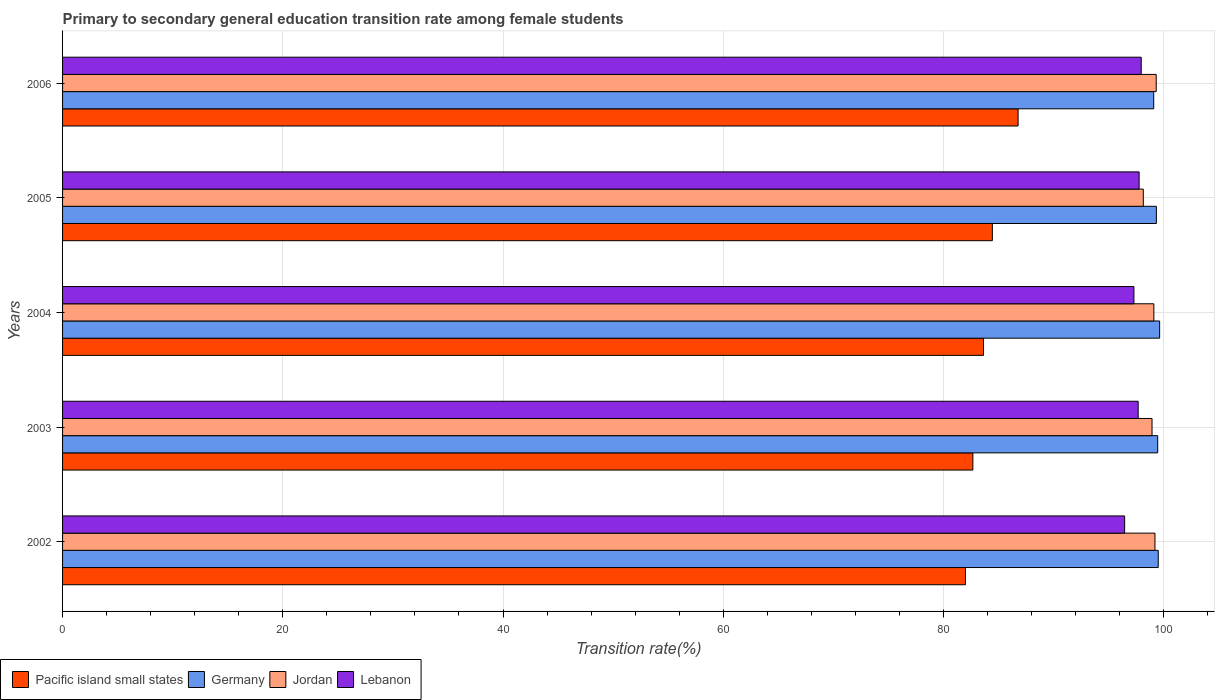Are the number of bars per tick equal to the number of legend labels?
Make the answer very short. Yes. How many bars are there on the 2nd tick from the top?
Provide a short and direct response. 4. How many bars are there on the 3rd tick from the bottom?
Offer a very short reply. 4. What is the label of the 3rd group of bars from the top?
Offer a very short reply. 2004. What is the transition rate in Pacific island small states in 2002?
Provide a short and direct response. 82. Across all years, what is the maximum transition rate in Pacific island small states?
Provide a short and direct response. 86.78. Across all years, what is the minimum transition rate in Lebanon?
Your answer should be compact. 96.46. In which year was the transition rate in Germany maximum?
Keep it short and to the point. 2004. In which year was the transition rate in Germany minimum?
Keep it short and to the point. 2006. What is the total transition rate in Germany in the graph?
Offer a terse response. 497.04. What is the difference between the transition rate in Jordan in 2002 and that in 2006?
Provide a succinct answer. -0.11. What is the difference between the transition rate in Lebanon in 2006 and the transition rate in Jordan in 2003?
Provide a short and direct response. -0.98. What is the average transition rate in Germany per year?
Make the answer very short. 99.41. In the year 2004, what is the difference between the transition rate in Germany and transition rate in Jordan?
Offer a very short reply. 0.52. What is the ratio of the transition rate in Lebanon in 2005 to that in 2006?
Make the answer very short. 1. Is the difference between the transition rate in Germany in 2005 and 2006 greater than the difference between the transition rate in Jordan in 2005 and 2006?
Give a very brief answer. Yes. What is the difference between the highest and the second highest transition rate in Pacific island small states?
Offer a very short reply. 2.34. What is the difference between the highest and the lowest transition rate in Germany?
Make the answer very short. 0.54. In how many years, is the transition rate in Lebanon greater than the average transition rate in Lebanon taken over all years?
Your answer should be compact. 3. Is the sum of the transition rate in Lebanon in 2004 and 2005 greater than the maximum transition rate in Jordan across all years?
Provide a succinct answer. Yes. What does the 3rd bar from the top in 2004 represents?
Your response must be concise. Germany. What does the 1st bar from the bottom in 2003 represents?
Give a very brief answer. Pacific island small states. Is it the case that in every year, the sum of the transition rate in Pacific island small states and transition rate in Germany is greater than the transition rate in Lebanon?
Your answer should be very brief. Yes. How many bars are there?
Make the answer very short. 20. Are all the bars in the graph horizontal?
Your answer should be very brief. Yes. How many years are there in the graph?
Keep it short and to the point. 5. What is the difference between two consecutive major ticks on the X-axis?
Offer a very short reply. 20. Are the values on the major ticks of X-axis written in scientific E-notation?
Make the answer very short. No. Where does the legend appear in the graph?
Your answer should be very brief. Bottom left. How are the legend labels stacked?
Keep it short and to the point. Horizontal. What is the title of the graph?
Your response must be concise. Primary to secondary general education transition rate among female students. What is the label or title of the X-axis?
Provide a short and direct response. Transition rate(%). What is the Transition rate(%) of Pacific island small states in 2002?
Provide a succinct answer. 82. What is the Transition rate(%) of Germany in 2002?
Your answer should be compact. 99.51. What is the Transition rate(%) of Jordan in 2002?
Offer a terse response. 99.21. What is the Transition rate(%) of Lebanon in 2002?
Keep it short and to the point. 96.46. What is the Transition rate(%) of Pacific island small states in 2003?
Make the answer very short. 82.67. What is the Transition rate(%) of Germany in 2003?
Ensure brevity in your answer.  99.46. What is the Transition rate(%) of Jordan in 2003?
Provide a short and direct response. 98.95. What is the Transition rate(%) of Lebanon in 2003?
Offer a very short reply. 97.69. What is the Transition rate(%) of Pacific island small states in 2004?
Your answer should be compact. 83.64. What is the Transition rate(%) in Germany in 2004?
Your answer should be very brief. 99.64. What is the Transition rate(%) in Jordan in 2004?
Your response must be concise. 99.11. What is the Transition rate(%) in Lebanon in 2004?
Provide a succinct answer. 97.3. What is the Transition rate(%) of Pacific island small states in 2005?
Keep it short and to the point. 84.44. What is the Transition rate(%) of Germany in 2005?
Offer a very short reply. 99.34. What is the Transition rate(%) in Jordan in 2005?
Provide a short and direct response. 98.15. What is the Transition rate(%) of Lebanon in 2005?
Provide a succinct answer. 97.77. What is the Transition rate(%) in Pacific island small states in 2006?
Provide a succinct answer. 86.78. What is the Transition rate(%) of Germany in 2006?
Your answer should be very brief. 99.1. What is the Transition rate(%) of Jordan in 2006?
Provide a short and direct response. 99.33. What is the Transition rate(%) of Lebanon in 2006?
Provide a short and direct response. 97.96. Across all years, what is the maximum Transition rate(%) of Pacific island small states?
Your response must be concise. 86.78. Across all years, what is the maximum Transition rate(%) of Germany?
Your answer should be compact. 99.64. Across all years, what is the maximum Transition rate(%) of Jordan?
Keep it short and to the point. 99.33. Across all years, what is the maximum Transition rate(%) of Lebanon?
Keep it short and to the point. 97.96. Across all years, what is the minimum Transition rate(%) of Pacific island small states?
Provide a short and direct response. 82. Across all years, what is the minimum Transition rate(%) of Germany?
Your answer should be very brief. 99.1. Across all years, what is the minimum Transition rate(%) of Jordan?
Keep it short and to the point. 98.15. Across all years, what is the minimum Transition rate(%) in Lebanon?
Give a very brief answer. 96.46. What is the total Transition rate(%) of Pacific island small states in the graph?
Offer a terse response. 419.54. What is the total Transition rate(%) in Germany in the graph?
Provide a short and direct response. 497.04. What is the total Transition rate(%) in Jordan in the graph?
Your answer should be compact. 494.75. What is the total Transition rate(%) of Lebanon in the graph?
Your answer should be very brief. 487.18. What is the difference between the Transition rate(%) in Pacific island small states in 2002 and that in 2003?
Ensure brevity in your answer.  -0.67. What is the difference between the Transition rate(%) of Germany in 2002 and that in 2003?
Your response must be concise. 0.05. What is the difference between the Transition rate(%) in Jordan in 2002 and that in 2003?
Your answer should be very brief. 0.27. What is the difference between the Transition rate(%) in Lebanon in 2002 and that in 2003?
Your response must be concise. -1.23. What is the difference between the Transition rate(%) in Pacific island small states in 2002 and that in 2004?
Your answer should be compact. -1.64. What is the difference between the Transition rate(%) of Germany in 2002 and that in 2004?
Provide a short and direct response. -0.13. What is the difference between the Transition rate(%) in Jordan in 2002 and that in 2004?
Ensure brevity in your answer.  0.1. What is the difference between the Transition rate(%) of Lebanon in 2002 and that in 2004?
Your answer should be compact. -0.84. What is the difference between the Transition rate(%) in Pacific island small states in 2002 and that in 2005?
Your answer should be very brief. -2.44. What is the difference between the Transition rate(%) in Germany in 2002 and that in 2005?
Keep it short and to the point. 0.17. What is the difference between the Transition rate(%) in Jordan in 2002 and that in 2005?
Ensure brevity in your answer.  1.06. What is the difference between the Transition rate(%) of Lebanon in 2002 and that in 2005?
Your response must be concise. -1.32. What is the difference between the Transition rate(%) in Pacific island small states in 2002 and that in 2006?
Your answer should be compact. -4.78. What is the difference between the Transition rate(%) of Germany in 2002 and that in 2006?
Ensure brevity in your answer.  0.41. What is the difference between the Transition rate(%) of Jordan in 2002 and that in 2006?
Make the answer very short. -0.11. What is the difference between the Transition rate(%) in Lebanon in 2002 and that in 2006?
Ensure brevity in your answer.  -1.51. What is the difference between the Transition rate(%) in Pacific island small states in 2003 and that in 2004?
Ensure brevity in your answer.  -0.97. What is the difference between the Transition rate(%) of Germany in 2003 and that in 2004?
Ensure brevity in your answer.  -0.18. What is the difference between the Transition rate(%) of Jordan in 2003 and that in 2004?
Ensure brevity in your answer.  -0.17. What is the difference between the Transition rate(%) in Lebanon in 2003 and that in 2004?
Your answer should be very brief. 0.39. What is the difference between the Transition rate(%) in Pacific island small states in 2003 and that in 2005?
Give a very brief answer. -1.77. What is the difference between the Transition rate(%) of Germany in 2003 and that in 2005?
Ensure brevity in your answer.  0.12. What is the difference between the Transition rate(%) in Jordan in 2003 and that in 2005?
Give a very brief answer. 0.79. What is the difference between the Transition rate(%) of Lebanon in 2003 and that in 2005?
Offer a terse response. -0.09. What is the difference between the Transition rate(%) of Pacific island small states in 2003 and that in 2006?
Keep it short and to the point. -4.11. What is the difference between the Transition rate(%) of Germany in 2003 and that in 2006?
Provide a short and direct response. 0.36. What is the difference between the Transition rate(%) of Jordan in 2003 and that in 2006?
Provide a short and direct response. -0.38. What is the difference between the Transition rate(%) of Lebanon in 2003 and that in 2006?
Give a very brief answer. -0.28. What is the difference between the Transition rate(%) in Pacific island small states in 2004 and that in 2005?
Your answer should be compact. -0.8. What is the difference between the Transition rate(%) of Germany in 2004 and that in 2005?
Offer a very short reply. 0.3. What is the difference between the Transition rate(%) of Jordan in 2004 and that in 2005?
Your answer should be compact. 0.96. What is the difference between the Transition rate(%) of Lebanon in 2004 and that in 2005?
Give a very brief answer. -0.47. What is the difference between the Transition rate(%) of Pacific island small states in 2004 and that in 2006?
Provide a short and direct response. -3.14. What is the difference between the Transition rate(%) of Germany in 2004 and that in 2006?
Your answer should be compact. 0.54. What is the difference between the Transition rate(%) in Jordan in 2004 and that in 2006?
Provide a succinct answer. -0.21. What is the difference between the Transition rate(%) of Lebanon in 2004 and that in 2006?
Your answer should be compact. -0.66. What is the difference between the Transition rate(%) of Pacific island small states in 2005 and that in 2006?
Provide a short and direct response. -2.34. What is the difference between the Transition rate(%) of Germany in 2005 and that in 2006?
Give a very brief answer. 0.24. What is the difference between the Transition rate(%) in Jordan in 2005 and that in 2006?
Your answer should be compact. -1.17. What is the difference between the Transition rate(%) of Lebanon in 2005 and that in 2006?
Give a very brief answer. -0.19. What is the difference between the Transition rate(%) in Pacific island small states in 2002 and the Transition rate(%) in Germany in 2003?
Make the answer very short. -17.46. What is the difference between the Transition rate(%) in Pacific island small states in 2002 and the Transition rate(%) in Jordan in 2003?
Your answer should be very brief. -16.94. What is the difference between the Transition rate(%) of Pacific island small states in 2002 and the Transition rate(%) of Lebanon in 2003?
Give a very brief answer. -15.68. What is the difference between the Transition rate(%) in Germany in 2002 and the Transition rate(%) in Jordan in 2003?
Give a very brief answer. 0.56. What is the difference between the Transition rate(%) in Germany in 2002 and the Transition rate(%) in Lebanon in 2003?
Your response must be concise. 1.82. What is the difference between the Transition rate(%) of Jordan in 2002 and the Transition rate(%) of Lebanon in 2003?
Your answer should be compact. 1.52. What is the difference between the Transition rate(%) of Pacific island small states in 2002 and the Transition rate(%) of Germany in 2004?
Make the answer very short. -17.63. What is the difference between the Transition rate(%) in Pacific island small states in 2002 and the Transition rate(%) in Jordan in 2004?
Provide a short and direct response. -17.11. What is the difference between the Transition rate(%) in Pacific island small states in 2002 and the Transition rate(%) in Lebanon in 2004?
Provide a succinct answer. -15.3. What is the difference between the Transition rate(%) in Germany in 2002 and the Transition rate(%) in Jordan in 2004?
Offer a very short reply. 0.4. What is the difference between the Transition rate(%) of Germany in 2002 and the Transition rate(%) of Lebanon in 2004?
Provide a succinct answer. 2.21. What is the difference between the Transition rate(%) of Jordan in 2002 and the Transition rate(%) of Lebanon in 2004?
Your answer should be very brief. 1.91. What is the difference between the Transition rate(%) in Pacific island small states in 2002 and the Transition rate(%) in Germany in 2005?
Your answer should be compact. -17.34. What is the difference between the Transition rate(%) of Pacific island small states in 2002 and the Transition rate(%) of Jordan in 2005?
Offer a very short reply. -16.15. What is the difference between the Transition rate(%) in Pacific island small states in 2002 and the Transition rate(%) in Lebanon in 2005?
Ensure brevity in your answer.  -15.77. What is the difference between the Transition rate(%) in Germany in 2002 and the Transition rate(%) in Jordan in 2005?
Offer a very short reply. 1.36. What is the difference between the Transition rate(%) of Germany in 2002 and the Transition rate(%) of Lebanon in 2005?
Your answer should be very brief. 1.74. What is the difference between the Transition rate(%) in Jordan in 2002 and the Transition rate(%) in Lebanon in 2005?
Give a very brief answer. 1.44. What is the difference between the Transition rate(%) of Pacific island small states in 2002 and the Transition rate(%) of Germany in 2006?
Your answer should be very brief. -17.1. What is the difference between the Transition rate(%) in Pacific island small states in 2002 and the Transition rate(%) in Jordan in 2006?
Your answer should be compact. -17.32. What is the difference between the Transition rate(%) in Pacific island small states in 2002 and the Transition rate(%) in Lebanon in 2006?
Keep it short and to the point. -15.96. What is the difference between the Transition rate(%) in Germany in 2002 and the Transition rate(%) in Jordan in 2006?
Keep it short and to the point. 0.18. What is the difference between the Transition rate(%) of Germany in 2002 and the Transition rate(%) of Lebanon in 2006?
Keep it short and to the point. 1.55. What is the difference between the Transition rate(%) in Jordan in 2002 and the Transition rate(%) in Lebanon in 2006?
Give a very brief answer. 1.25. What is the difference between the Transition rate(%) in Pacific island small states in 2003 and the Transition rate(%) in Germany in 2004?
Provide a succinct answer. -16.96. What is the difference between the Transition rate(%) of Pacific island small states in 2003 and the Transition rate(%) of Jordan in 2004?
Give a very brief answer. -16.44. What is the difference between the Transition rate(%) in Pacific island small states in 2003 and the Transition rate(%) in Lebanon in 2004?
Your response must be concise. -14.63. What is the difference between the Transition rate(%) of Germany in 2003 and the Transition rate(%) of Jordan in 2004?
Give a very brief answer. 0.35. What is the difference between the Transition rate(%) of Germany in 2003 and the Transition rate(%) of Lebanon in 2004?
Your answer should be compact. 2.16. What is the difference between the Transition rate(%) in Jordan in 2003 and the Transition rate(%) in Lebanon in 2004?
Provide a short and direct response. 1.64. What is the difference between the Transition rate(%) of Pacific island small states in 2003 and the Transition rate(%) of Germany in 2005?
Your answer should be compact. -16.67. What is the difference between the Transition rate(%) in Pacific island small states in 2003 and the Transition rate(%) in Jordan in 2005?
Ensure brevity in your answer.  -15.48. What is the difference between the Transition rate(%) in Pacific island small states in 2003 and the Transition rate(%) in Lebanon in 2005?
Make the answer very short. -15.1. What is the difference between the Transition rate(%) in Germany in 2003 and the Transition rate(%) in Jordan in 2005?
Offer a very short reply. 1.31. What is the difference between the Transition rate(%) in Germany in 2003 and the Transition rate(%) in Lebanon in 2005?
Offer a terse response. 1.69. What is the difference between the Transition rate(%) in Jordan in 2003 and the Transition rate(%) in Lebanon in 2005?
Provide a succinct answer. 1.17. What is the difference between the Transition rate(%) of Pacific island small states in 2003 and the Transition rate(%) of Germany in 2006?
Give a very brief answer. -16.42. What is the difference between the Transition rate(%) of Pacific island small states in 2003 and the Transition rate(%) of Jordan in 2006?
Your answer should be compact. -16.65. What is the difference between the Transition rate(%) in Pacific island small states in 2003 and the Transition rate(%) in Lebanon in 2006?
Your answer should be very brief. -15.29. What is the difference between the Transition rate(%) in Germany in 2003 and the Transition rate(%) in Jordan in 2006?
Make the answer very short. 0.13. What is the difference between the Transition rate(%) of Germany in 2003 and the Transition rate(%) of Lebanon in 2006?
Provide a succinct answer. 1.5. What is the difference between the Transition rate(%) in Jordan in 2003 and the Transition rate(%) in Lebanon in 2006?
Your answer should be compact. 0.98. What is the difference between the Transition rate(%) of Pacific island small states in 2004 and the Transition rate(%) of Germany in 2005?
Your response must be concise. -15.7. What is the difference between the Transition rate(%) of Pacific island small states in 2004 and the Transition rate(%) of Jordan in 2005?
Your answer should be compact. -14.51. What is the difference between the Transition rate(%) of Pacific island small states in 2004 and the Transition rate(%) of Lebanon in 2005?
Make the answer very short. -14.13. What is the difference between the Transition rate(%) of Germany in 2004 and the Transition rate(%) of Jordan in 2005?
Give a very brief answer. 1.48. What is the difference between the Transition rate(%) in Germany in 2004 and the Transition rate(%) in Lebanon in 2005?
Your answer should be very brief. 1.86. What is the difference between the Transition rate(%) in Jordan in 2004 and the Transition rate(%) in Lebanon in 2005?
Your answer should be compact. 1.34. What is the difference between the Transition rate(%) in Pacific island small states in 2004 and the Transition rate(%) in Germany in 2006?
Offer a terse response. -15.46. What is the difference between the Transition rate(%) in Pacific island small states in 2004 and the Transition rate(%) in Jordan in 2006?
Ensure brevity in your answer.  -15.69. What is the difference between the Transition rate(%) of Pacific island small states in 2004 and the Transition rate(%) of Lebanon in 2006?
Your answer should be compact. -14.32. What is the difference between the Transition rate(%) of Germany in 2004 and the Transition rate(%) of Jordan in 2006?
Your answer should be very brief. 0.31. What is the difference between the Transition rate(%) in Germany in 2004 and the Transition rate(%) in Lebanon in 2006?
Give a very brief answer. 1.67. What is the difference between the Transition rate(%) of Jordan in 2004 and the Transition rate(%) of Lebanon in 2006?
Your response must be concise. 1.15. What is the difference between the Transition rate(%) of Pacific island small states in 2005 and the Transition rate(%) of Germany in 2006?
Your response must be concise. -14.65. What is the difference between the Transition rate(%) of Pacific island small states in 2005 and the Transition rate(%) of Jordan in 2006?
Offer a very short reply. -14.88. What is the difference between the Transition rate(%) of Pacific island small states in 2005 and the Transition rate(%) of Lebanon in 2006?
Offer a terse response. -13.52. What is the difference between the Transition rate(%) in Germany in 2005 and the Transition rate(%) in Jordan in 2006?
Provide a succinct answer. 0.01. What is the difference between the Transition rate(%) of Germany in 2005 and the Transition rate(%) of Lebanon in 2006?
Offer a very short reply. 1.38. What is the difference between the Transition rate(%) of Jordan in 2005 and the Transition rate(%) of Lebanon in 2006?
Make the answer very short. 0.19. What is the average Transition rate(%) of Pacific island small states per year?
Offer a very short reply. 83.91. What is the average Transition rate(%) of Germany per year?
Your answer should be compact. 99.41. What is the average Transition rate(%) in Jordan per year?
Make the answer very short. 98.95. What is the average Transition rate(%) of Lebanon per year?
Provide a short and direct response. 97.44. In the year 2002, what is the difference between the Transition rate(%) in Pacific island small states and Transition rate(%) in Germany?
Provide a short and direct response. -17.51. In the year 2002, what is the difference between the Transition rate(%) of Pacific island small states and Transition rate(%) of Jordan?
Give a very brief answer. -17.21. In the year 2002, what is the difference between the Transition rate(%) of Pacific island small states and Transition rate(%) of Lebanon?
Offer a terse response. -14.46. In the year 2002, what is the difference between the Transition rate(%) in Germany and Transition rate(%) in Jordan?
Ensure brevity in your answer.  0.3. In the year 2002, what is the difference between the Transition rate(%) of Germany and Transition rate(%) of Lebanon?
Make the answer very short. 3.05. In the year 2002, what is the difference between the Transition rate(%) in Jordan and Transition rate(%) in Lebanon?
Your response must be concise. 2.75. In the year 2003, what is the difference between the Transition rate(%) of Pacific island small states and Transition rate(%) of Germany?
Your answer should be compact. -16.79. In the year 2003, what is the difference between the Transition rate(%) of Pacific island small states and Transition rate(%) of Jordan?
Give a very brief answer. -16.27. In the year 2003, what is the difference between the Transition rate(%) of Pacific island small states and Transition rate(%) of Lebanon?
Ensure brevity in your answer.  -15.01. In the year 2003, what is the difference between the Transition rate(%) in Germany and Transition rate(%) in Jordan?
Your answer should be compact. 0.51. In the year 2003, what is the difference between the Transition rate(%) in Germany and Transition rate(%) in Lebanon?
Your answer should be compact. 1.77. In the year 2003, what is the difference between the Transition rate(%) in Jordan and Transition rate(%) in Lebanon?
Keep it short and to the point. 1.26. In the year 2004, what is the difference between the Transition rate(%) in Pacific island small states and Transition rate(%) in Germany?
Your answer should be very brief. -16. In the year 2004, what is the difference between the Transition rate(%) of Pacific island small states and Transition rate(%) of Jordan?
Make the answer very short. -15.47. In the year 2004, what is the difference between the Transition rate(%) in Pacific island small states and Transition rate(%) in Lebanon?
Your answer should be compact. -13.66. In the year 2004, what is the difference between the Transition rate(%) in Germany and Transition rate(%) in Jordan?
Offer a terse response. 0.52. In the year 2004, what is the difference between the Transition rate(%) of Germany and Transition rate(%) of Lebanon?
Your answer should be very brief. 2.33. In the year 2004, what is the difference between the Transition rate(%) of Jordan and Transition rate(%) of Lebanon?
Provide a short and direct response. 1.81. In the year 2005, what is the difference between the Transition rate(%) in Pacific island small states and Transition rate(%) in Germany?
Ensure brevity in your answer.  -14.9. In the year 2005, what is the difference between the Transition rate(%) of Pacific island small states and Transition rate(%) of Jordan?
Keep it short and to the point. -13.71. In the year 2005, what is the difference between the Transition rate(%) in Pacific island small states and Transition rate(%) in Lebanon?
Give a very brief answer. -13.33. In the year 2005, what is the difference between the Transition rate(%) of Germany and Transition rate(%) of Jordan?
Provide a succinct answer. 1.19. In the year 2005, what is the difference between the Transition rate(%) in Germany and Transition rate(%) in Lebanon?
Give a very brief answer. 1.57. In the year 2005, what is the difference between the Transition rate(%) in Jordan and Transition rate(%) in Lebanon?
Your answer should be very brief. 0.38. In the year 2006, what is the difference between the Transition rate(%) of Pacific island small states and Transition rate(%) of Germany?
Keep it short and to the point. -12.32. In the year 2006, what is the difference between the Transition rate(%) in Pacific island small states and Transition rate(%) in Jordan?
Offer a terse response. -12.54. In the year 2006, what is the difference between the Transition rate(%) of Pacific island small states and Transition rate(%) of Lebanon?
Provide a succinct answer. -11.18. In the year 2006, what is the difference between the Transition rate(%) of Germany and Transition rate(%) of Jordan?
Give a very brief answer. -0.23. In the year 2006, what is the difference between the Transition rate(%) in Germany and Transition rate(%) in Lebanon?
Your answer should be compact. 1.14. In the year 2006, what is the difference between the Transition rate(%) in Jordan and Transition rate(%) in Lebanon?
Keep it short and to the point. 1.36. What is the ratio of the Transition rate(%) of Pacific island small states in 2002 to that in 2003?
Offer a very short reply. 0.99. What is the ratio of the Transition rate(%) of Jordan in 2002 to that in 2003?
Ensure brevity in your answer.  1. What is the ratio of the Transition rate(%) in Lebanon in 2002 to that in 2003?
Give a very brief answer. 0.99. What is the ratio of the Transition rate(%) in Pacific island small states in 2002 to that in 2004?
Make the answer very short. 0.98. What is the ratio of the Transition rate(%) in Pacific island small states in 2002 to that in 2005?
Provide a short and direct response. 0.97. What is the ratio of the Transition rate(%) in Germany in 2002 to that in 2005?
Offer a terse response. 1. What is the ratio of the Transition rate(%) in Jordan in 2002 to that in 2005?
Provide a succinct answer. 1.01. What is the ratio of the Transition rate(%) in Lebanon in 2002 to that in 2005?
Provide a short and direct response. 0.99. What is the ratio of the Transition rate(%) of Pacific island small states in 2002 to that in 2006?
Offer a terse response. 0.94. What is the ratio of the Transition rate(%) of Germany in 2002 to that in 2006?
Your answer should be compact. 1. What is the ratio of the Transition rate(%) in Lebanon in 2002 to that in 2006?
Offer a terse response. 0.98. What is the ratio of the Transition rate(%) in Pacific island small states in 2003 to that in 2004?
Provide a succinct answer. 0.99. What is the ratio of the Transition rate(%) in Pacific island small states in 2003 to that in 2005?
Your answer should be compact. 0.98. What is the ratio of the Transition rate(%) in Germany in 2003 to that in 2005?
Offer a terse response. 1. What is the ratio of the Transition rate(%) of Pacific island small states in 2003 to that in 2006?
Provide a short and direct response. 0.95. What is the ratio of the Transition rate(%) of Germany in 2003 to that in 2006?
Your response must be concise. 1. What is the ratio of the Transition rate(%) in Pacific island small states in 2004 to that in 2005?
Provide a succinct answer. 0.99. What is the ratio of the Transition rate(%) in Germany in 2004 to that in 2005?
Make the answer very short. 1. What is the ratio of the Transition rate(%) of Jordan in 2004 to that in 2005?
Ensure brevity in your answer.  1.01. What is the ratio of the Transition rate(%) in Pacific island small states in 2004 to that in 2006?
Give a very brief answer. 0.96. What is the ratio of the Transition rate(%) of Germany in 2004 to that in 2006?
Ensure brevity in your answer.  1.01. What is the ratio of the Transition rate(%) of Pacific island small states in 2005 to that in 2006?
Make the answer very short. 0.97. What is the ratio of the Transition rate(%) in Jordan in 2005 to that in 2006?
Keep it short and to the point. 0.99. What is the ratio of the Transition rate(%) of Lebanon in 2005 to that in 2006?
Ensure brevity in your answer.  1. What is the difference between the highest and the second highest Transition rate(%) in Pacific island small states?
Offer a terse response. 2.34. What is the difference between the highest and the second highest Transition rate(%) of Germany?
Ensure brevity in your answer.  0.13. What is the difference between the highest and the second highest Transition rate(%) in Jordan?
Your response must be concise. 0.11. What is the difference between the highest and the second highest Transition rate(%) of Lebanon?
Give a very brief answer. 0.19. What is the difference between the highest and the lowest Transition rate(%) of Pacific island small states?
Ensure brevity in your answer.  4.78. What is the difference between the highest and the lowest Transition rate(%) of Germany?
Your answer should be compact. 0.54. What is the difference between the highest and the lowest Transition rate(%) of Jordan?
Offer a very short reply. 1.17. What is the difference between the highest and the lowest Transition rate(%) of Lebanon?
Offer a very short reply. 1.51. 